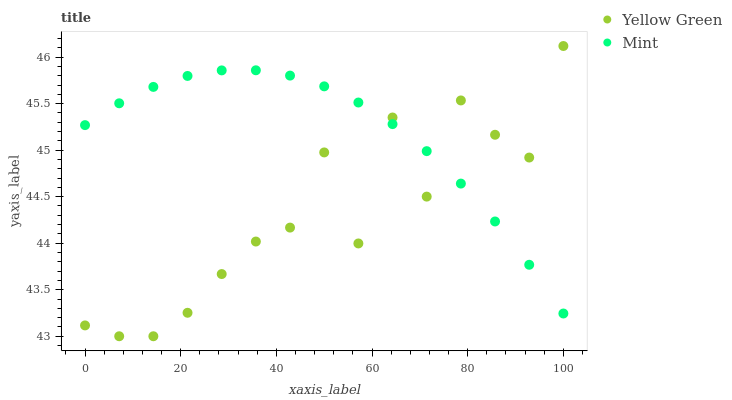Does Yellow Green have the minimum area under the curve?
Answer yes or no. Yes. Does Mint have the maximum area under the curve?
Answer yes or no. Yes. Does Yellow Green have the maximum area under the curve?
Answer yes or no. No. Is Mint the smoothest?
Answer yes or no. Yes. Is Yellow Green the roughest?
Answer yes or no. Yes. Is Yellow Green the smoothest?
Answer yes or no. No. Does Yellow Green have the lowest value?
Answer yes or no. Yes. Does Yellow Green have the highest value?
Answer yes or no. Yes. Does Mint intersect Yellow Green?
Answer yes or no. Yes. Is Mint less than Yellow Green?
Answer yes or no. No. Is Mint greater than Yellow Green?
Answer yes or no. No. 